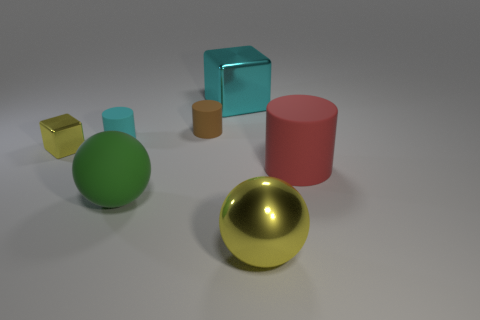How many objects are either tiny cyan rubber objects or large matte objects that are right of the green sphere?
Your answer should be compact. 2. Is the number of cyan rubber cylinders less than the number of metal things?
Keep it short and to the point. Yes. Is the number of red objects greater than the number of purple rubber cylinders?
Offer a very short reply. Yes. What number of other things are the same material as the large block?
Your response must be concise. 2. What number of big green spheres are behind the yellow thing to the right of the metal block behind the small cube?
Give a very brief answer. 1. What number of metallic things are either red cylinders or yellow objects?
Your answer should be very brief. 2. What is the size of the yellow shiny thing that is right of the yellow metallic thing behind the big red thing?
Make the answer very short. Large. There is a cylinder on the right side of the brown object; is it the same color as the shiny object that is behind the yellow metallic block?
Your answer should be very brief. No. What is the color of the thing that is on the right side of the brown rubber object and behind the tiny cyan cylinder?
Offer a very short reply. Cyan. Are the tiny yellow block and the green thing made of the same material?
Ensure brevity in your answer.  No. 